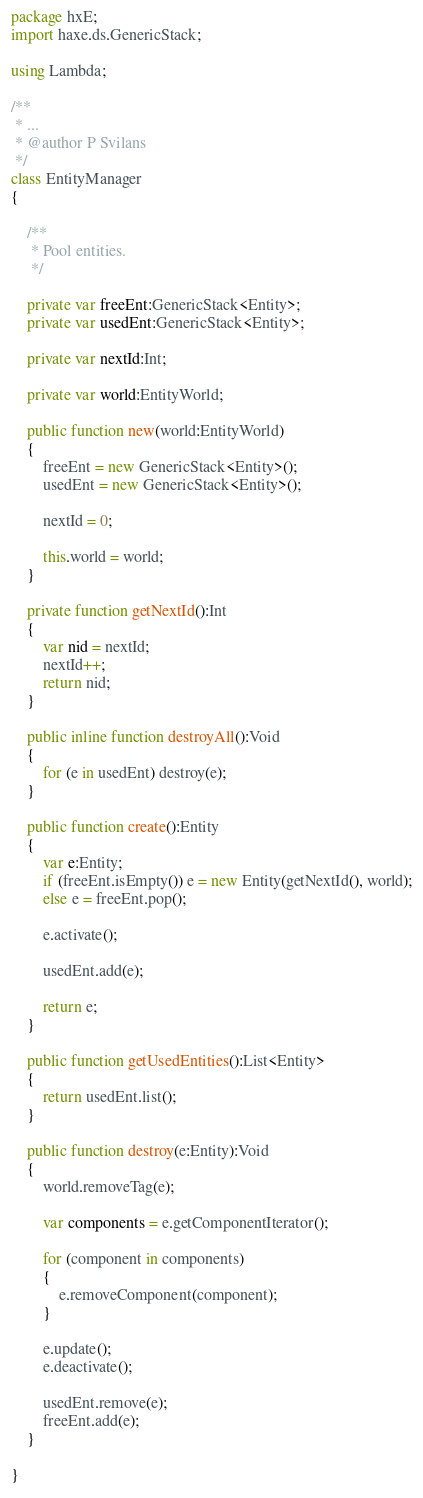<code> <loc_0><loc_0><loc_500><loc_500><_Haxe_>package hxE;
import haxe.ds.GenericStack;

using Lambda;

/**
 * ...
 * @author P Svilans
 */
class EntityManager
{
	
	/**
	 * Pool entities.
	 */
	
	private var freeEnt:GenericStack<Entity>;
	private var usedEnt:GenericStack<Entity>;
	
	private var nextId:Int;
	
	private var world:EntityWorld;
	
	public function new(world:EntityWorld) 
	{
		freeEnt = new GenericStack<Entity>();
		usedEnt = new GenericStack<Entity>();
		
		nextId = 0;
		
		this.world = world;
	}
	
	private function getNextId():Int
	{
		var nid = nextId;
		nextId++;
		return nid;
	}
	
	public inline function destroyAll():Void
	{
		for (e in usedEnt) destroy(e);
	}
	
	public function create():Entity
	{
		var e:Entity;
		if (freeEnt.isEmpty()) e = new Entity(getNextId(), world);
		else e = freeEnt.pop();
		
		e.activate();
		
		usedEnt.add(e);
		
		return e;
	}
	
	public function getUsedEntities():List<Entity>
	{
		return usedEnt.list();
	}
	
	public function destroy(e:Entity):Void
	{
		world.removeTag(e);
		
		var components = e.getComponentIterator();
		
		for (component in components)
		{
			e.removeComponent(component);
		}
		
		e.update();
		e.deactivate();
		
		usedEnt.remove(e);
		freeEnt.add(e);
	}
	
}</code> 